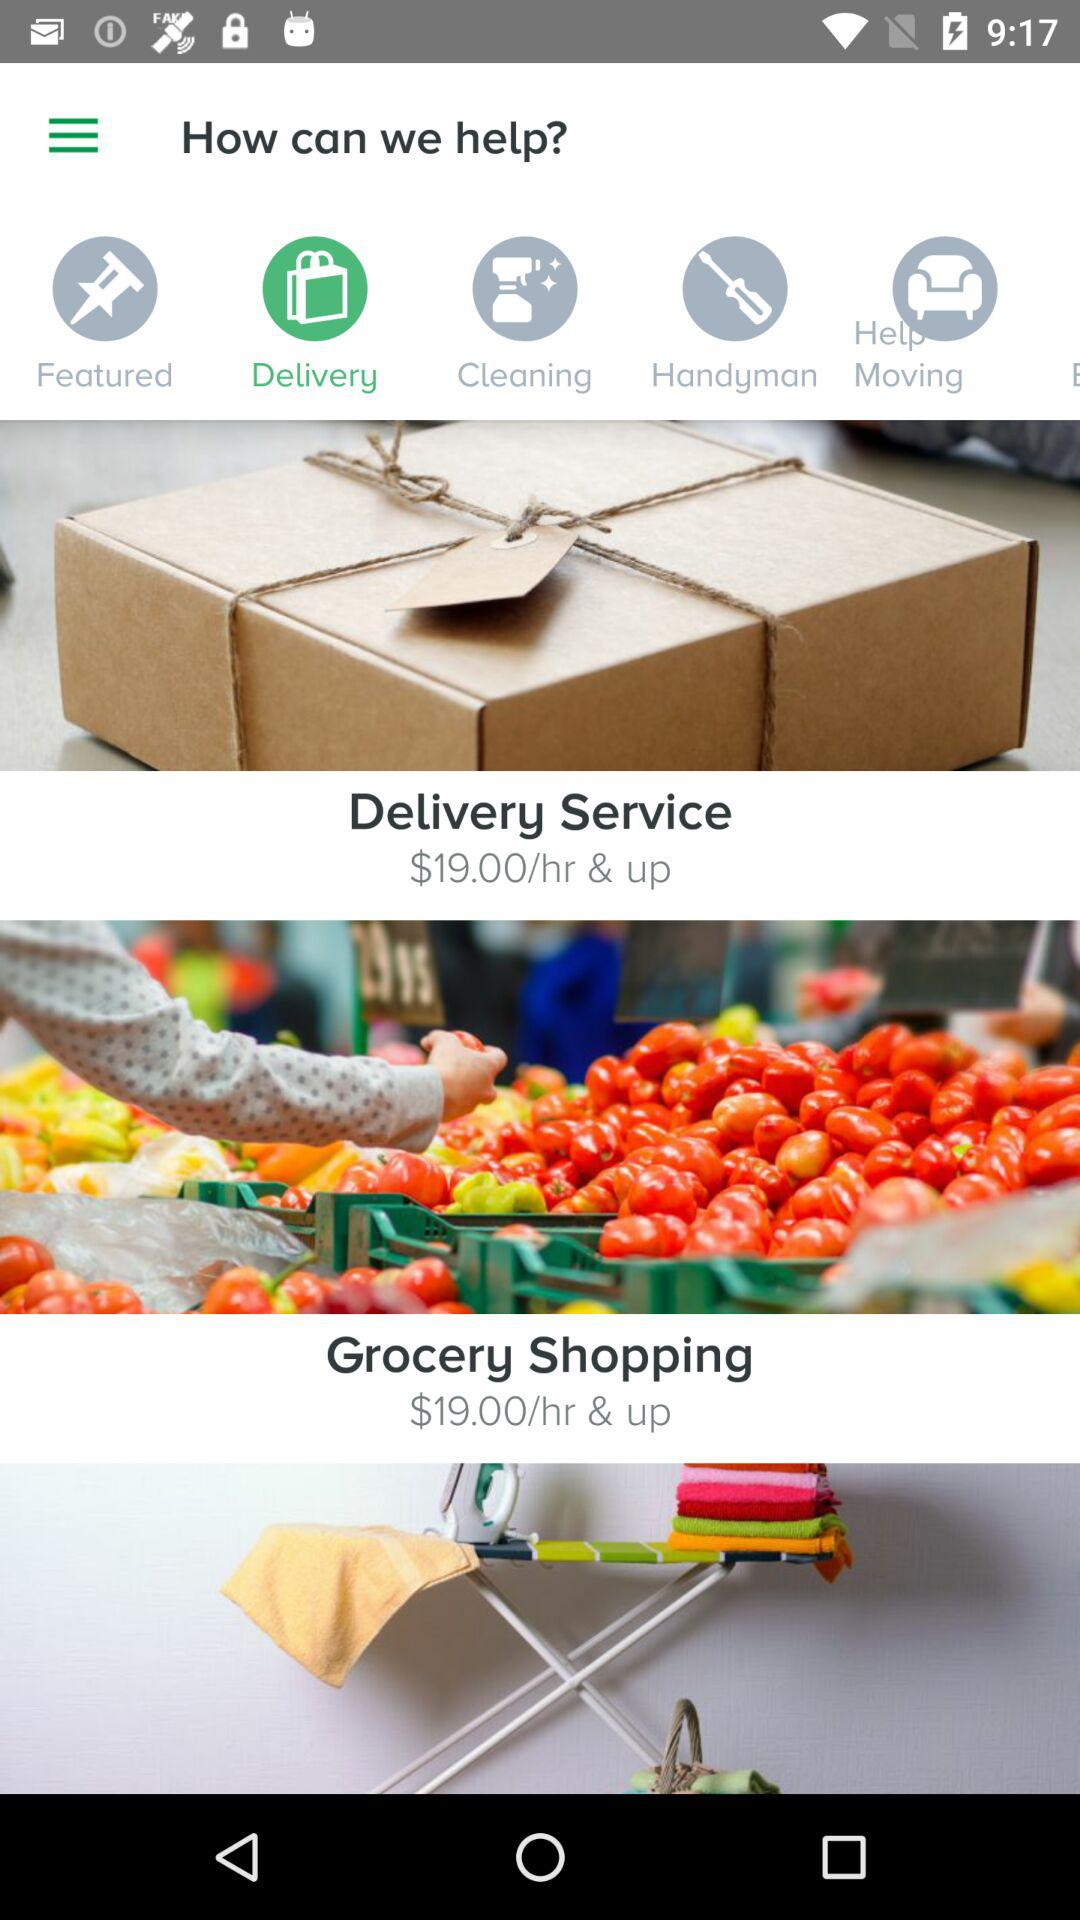What is the price per hour of delivery service? The price is $19 per hour and up. 